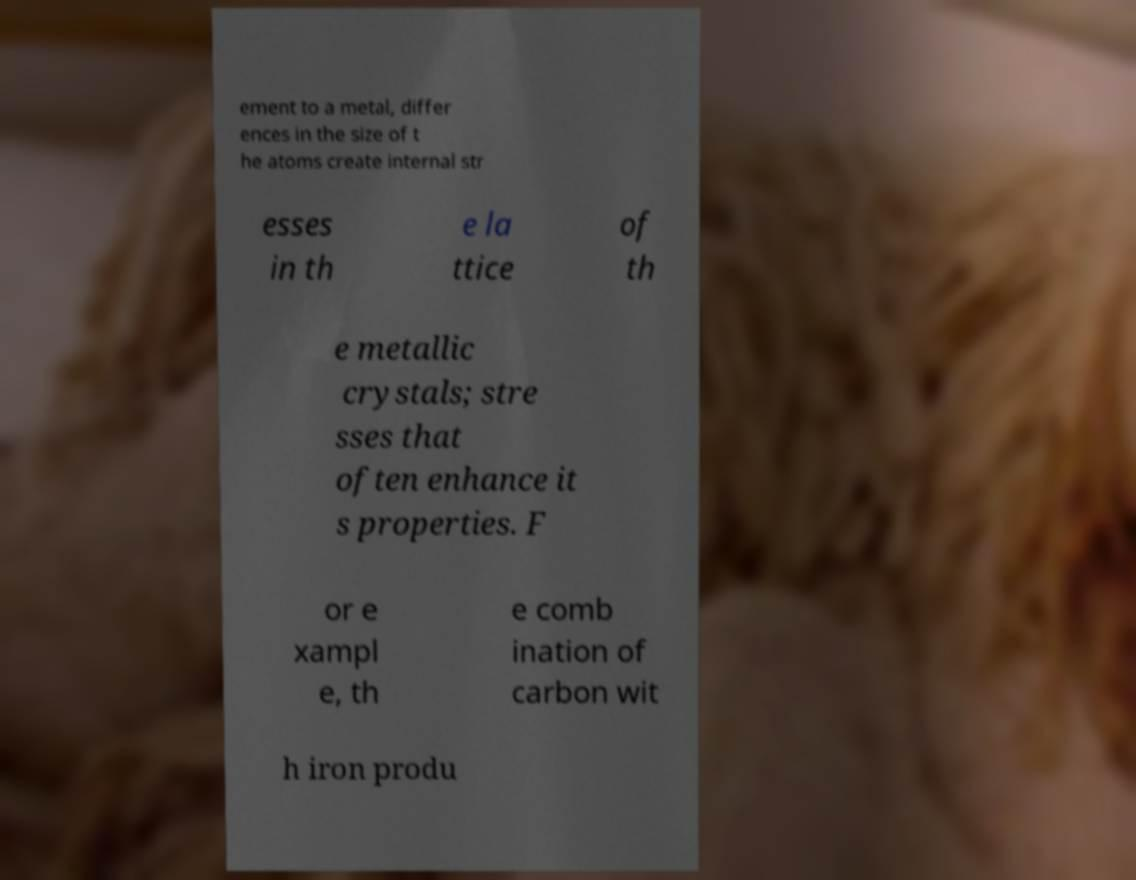Can you read and provide the text displayed in the image?This photo seems to have some interesting text. Can you extract and type it out for me? ement to a metal, differ ences in the size of t he atoms create internal str esses in th e la ttice of th e metallic crystals; stre sses that often enhance it s properties. F or e xampl e, th e comb ination of carbon wit h iron produ 